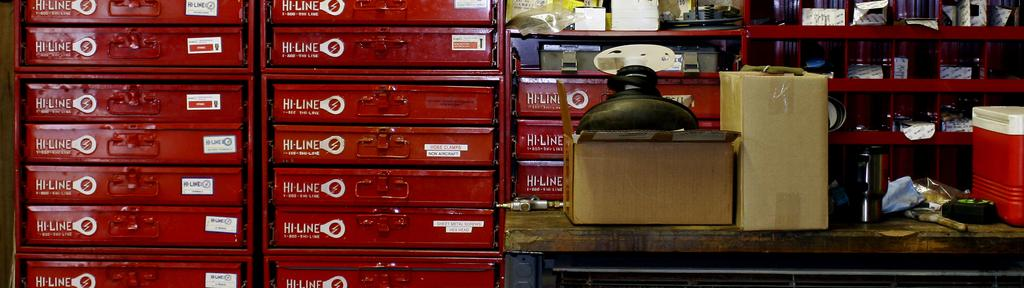Provide a one-sentence caption for the provided image. Rows of Hi-Line red trays next to a table with boxes on top. 